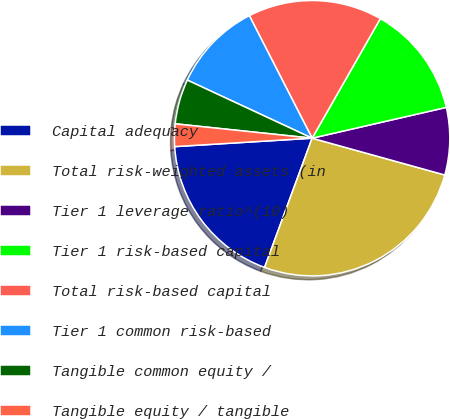<chart> <loc_0><loc_0><loc_500><loc_500><pie_chart><fcel>Capital adequacy<fcel>Total risk-weighted assets (in<fcel>Tier 1 leverage ratio^(10)<fcel>Tier 1 risk-based capital<fcel>Total risk-based capital<fcel>Tier 1 common risk-based<fcel>Tangible common equity /<fcel>Tangible equity / tangible<nl><fcel>18.42%<fcel>26.31%<fcel>7.9%<fcel>13.16%<fcel>15.79%<fcel>10.53%<fcel>5.27%<fcel>2.64%<nl></chart> 